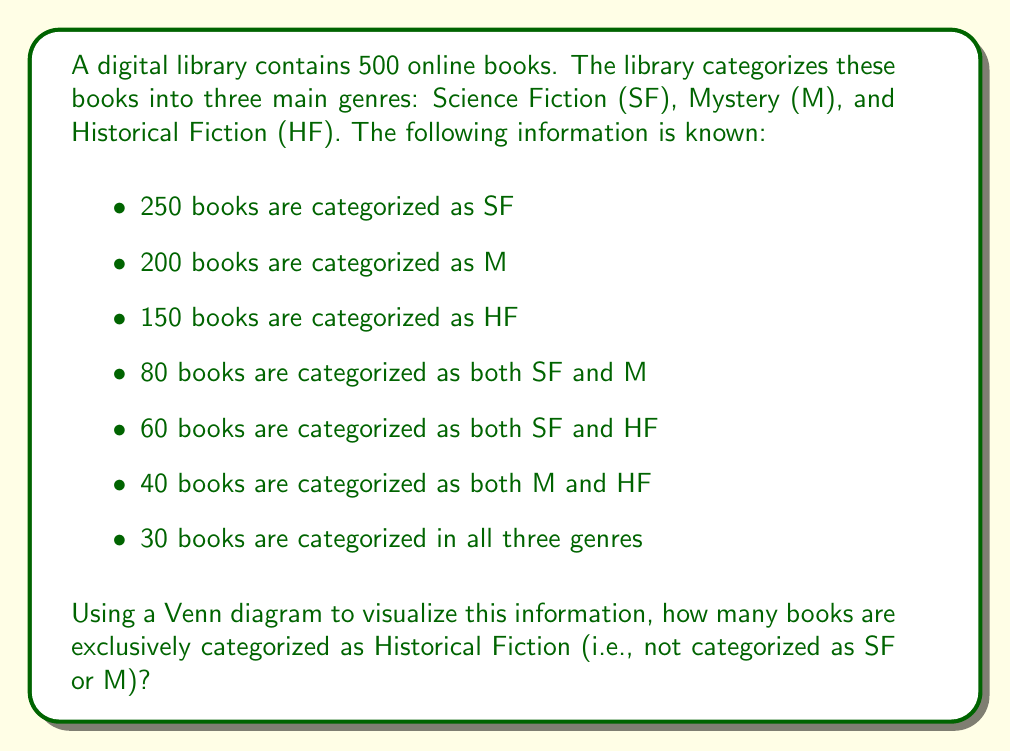Could you help me with this problem? Let's approach this step-by-step using a Venn diagram and set theory:

1. First, let's draw a Venn diagram with three intersecting circles representing SF, M, and HF.

2. We'll fill in the known information:
   - Center (all three genres): 30
   - SF ∩ M (not including center): 80 - 30 = 50
   - SF ∩ HF (not including center): 60 - 30 = 30
   - M ∩ HF (not including center): 40 - 30 = 10

3. Now, let's calculate the number of books in each genre that are not in the intersections:
   - SF only: 250 - (50 + 30 + 30) = 140
   - M only: 200 - (50 + 10 + 30) = 110
   - HF only: This is what we're trying to find, let's call it x

4. We can set up an equation based on the total number of books:
   $$(140 + 110 + x) + (50 + 30 + 10) + 30 = 500$$

5. Simplify:
   $$250 + x + 90 + 30 = 500$$
   $$370 + x = 500$$

6. Solve for x:
   $$x = 500 - 370 = 130$$

Therefore, 130 books are exclusively categorized as Historical Fiction.

[asy]
unitsize(1cm);

pair A = (0,0), B = (2,0), C = (1,1.732);
real r = 1.5;

fill(circle(A,r), lightred);
fill(circle(B,r), lightgreen);
fill(circle(C,r), lightblue);

draw(circle(A,r));
draw(circle(B,r));
draw(circle(C,r));

label("SF", A, SW);
label("M", B, SE);
label("HF", C, N);

label("140", (-1,-0.5));
label("110", (3,-0.5));
label("130", (1,2.5));

label("50", (1,-0.5));
label("30", (0,1));
label("10", (2,1));

label("30", (1,0.577));
[/asy]
Answer: 130 books are exclusively categorized as Historical Fiction. 